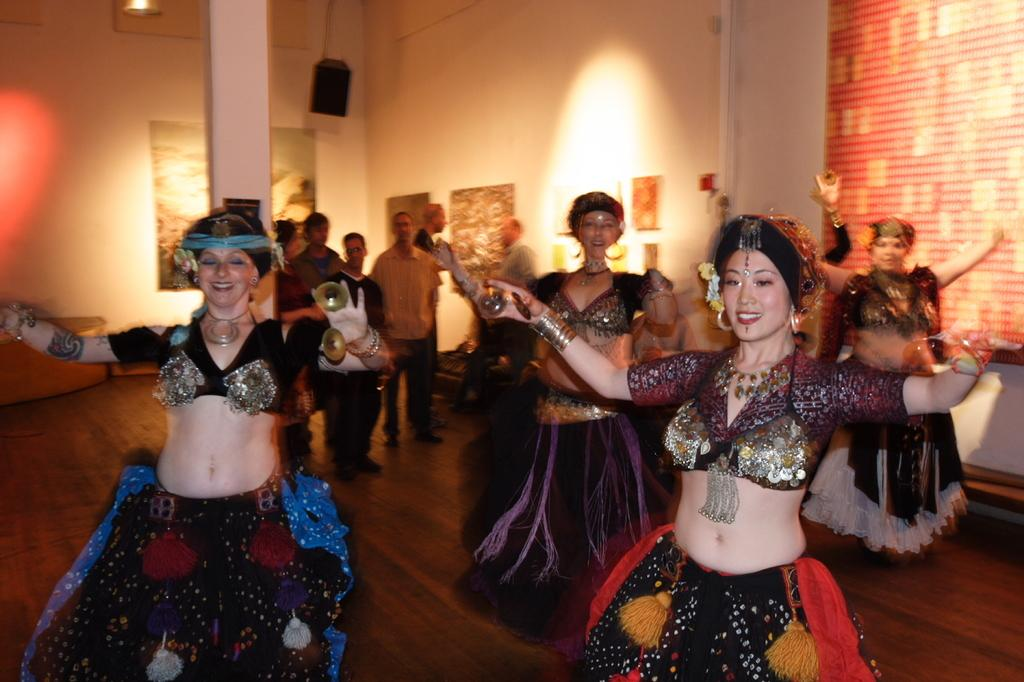What are the women in the image doing? The women in the image are dancing. Where are the women dancing? The women are dancing on the floor. What can be seen in the background of the image? In the background of the image, there are persons, speakers, photo frames, and a wall. What type of shock can be seen in the image? There is no shock present in the image; it features a group of women dancing on the floor with a background containing persons, speakers, photo frames, and a wall. 